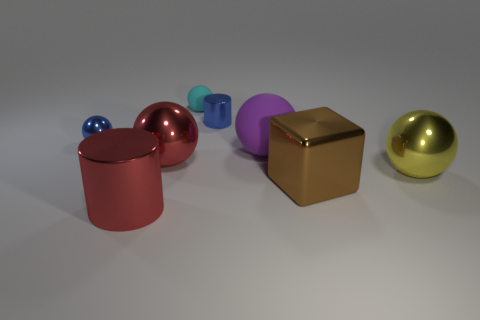Subtract all large balls. How many balls are left? 2 Subtract all cyan balls. How many balls are left? 4 Add 2 large red shiny blocks. How many objects exist? 10 Subtract all blue spheres. Subtract all yellow cubes. How many spheres are left? 4 Subtract all cylinders. How many objects are left? 6 Add 8 tiny blue blocks. How many tiny blue blocks exist? 8 Subtract 1 purple spheres. How many objects are left? 7 Subtract all large yellow rubber cylinders. Subtract all cyan spheres. How many objects are left? 7 Add 1 big rubber spheres. How many big rubber spheres are left? 2 